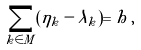Convert formula to latex. <formula><loc_0><loc_0><loc_500><loc_500>\sum _ { k \in M } ( \eta _ { k } - \lambda _ { k } ) = h \, ,</formula> 